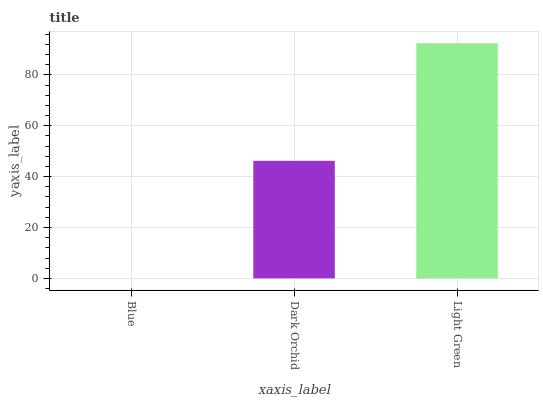Is Blue the minimum?
Answer yes or no. Yes. Is Light Green the maximum?
Answer yes or no. Yes. Is Dark Orchid the minimum?
Answer yes or no. No. Is Dark Orchid the maximum?
Answer yes or no. No. Is Dark Orchid greater than Blue?
Answer yes or no. Yes. Is Blue less than Dark Orchid?
Answer yes or no. Yes. Is Blue greater than Dark Orchid?
Answer yes or no. No. Is Dark Orchid less than Blue?
Answer yes or no. No. Is Dark Orchid the high median?
Answer yes or no. Yes. Is Dark Orchid the low median?
Answer yes or no. Yes. Is Light Green the high median?
Answer yes or no. No. Is Blue the low median?
Answer yes or no. No. 